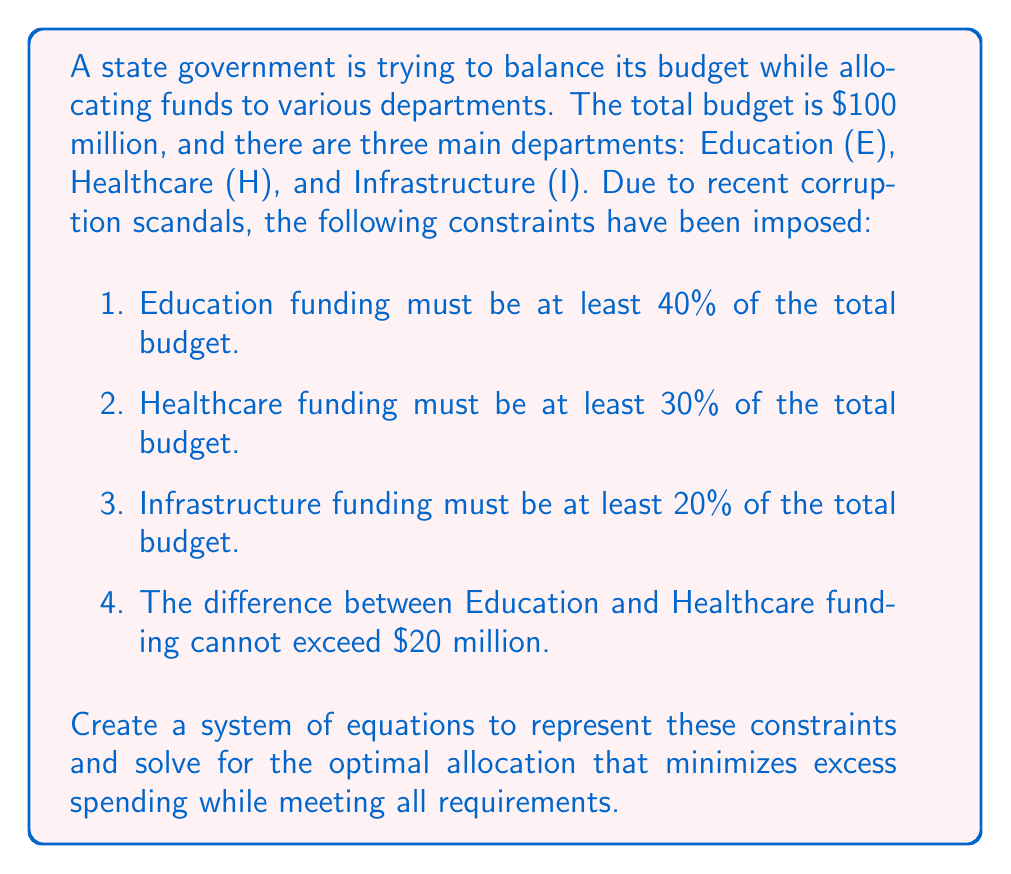Provide a solution to this math problem. Let's approach this step-by-step:

1. Define variables:
   $E$ = Education funding
   $H$ = Healthcare funding
   $I$ = Infrastructure funding

2. Set up the equations based on the constraints:

   Total budget: $E + H + I = 100$ (in millions)
   Education: $E \geq 40$
   Healthcare: $H \geq 30$
   Infrastructure: $I \geq 20$
   Difference constraint: $-20 \leq E - H \leq 20$

3. To minimize excess spending, we want to make each department's funding as close to its minimum as possible while satisfying all constraints.

4. Start with the minimum values:
   $E = 40$, $H = 30$, $I = 20$

5. This adds up to 90 million, leaving 10 million to allocate.

6. We can't add all 10 million to Infrastructure, as it would violate the difference constraint between Education and Healthcare.

7. The optimal solution is to add 5 million each to Education and Healthcare:
   $E = 45$, $H = 35$, $I = 20$

8. Verify the constraints:
   Total: $45 + 35 + 20 = 100$ (satisfied)
   Education: $45 \geq 40$ (satisfied)
   Healthcare: $35 \geq 30$ (satisfied)
   Infrastructure: $20 \geq 20$ (satisfied)
   Difference: $45 - 35 = 10$, which is $\leq 20$ (satisfied)

Therefore, the optimal allocation that minimizes excess spending while meeting all requirements is:
Education: $45 million
Healthcare: $35 million
Infrastructure: $20 million
Answer: $E = 45$, $H = 35$, $I = 20$ (in millions) 